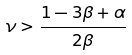Convert formula to latex. <formula><loc_0><loc_0><loc_500><loc_500>\nu > \frac { 1 - 3 { \beta } + \alpha } { 2 { \beta } }</formula> 